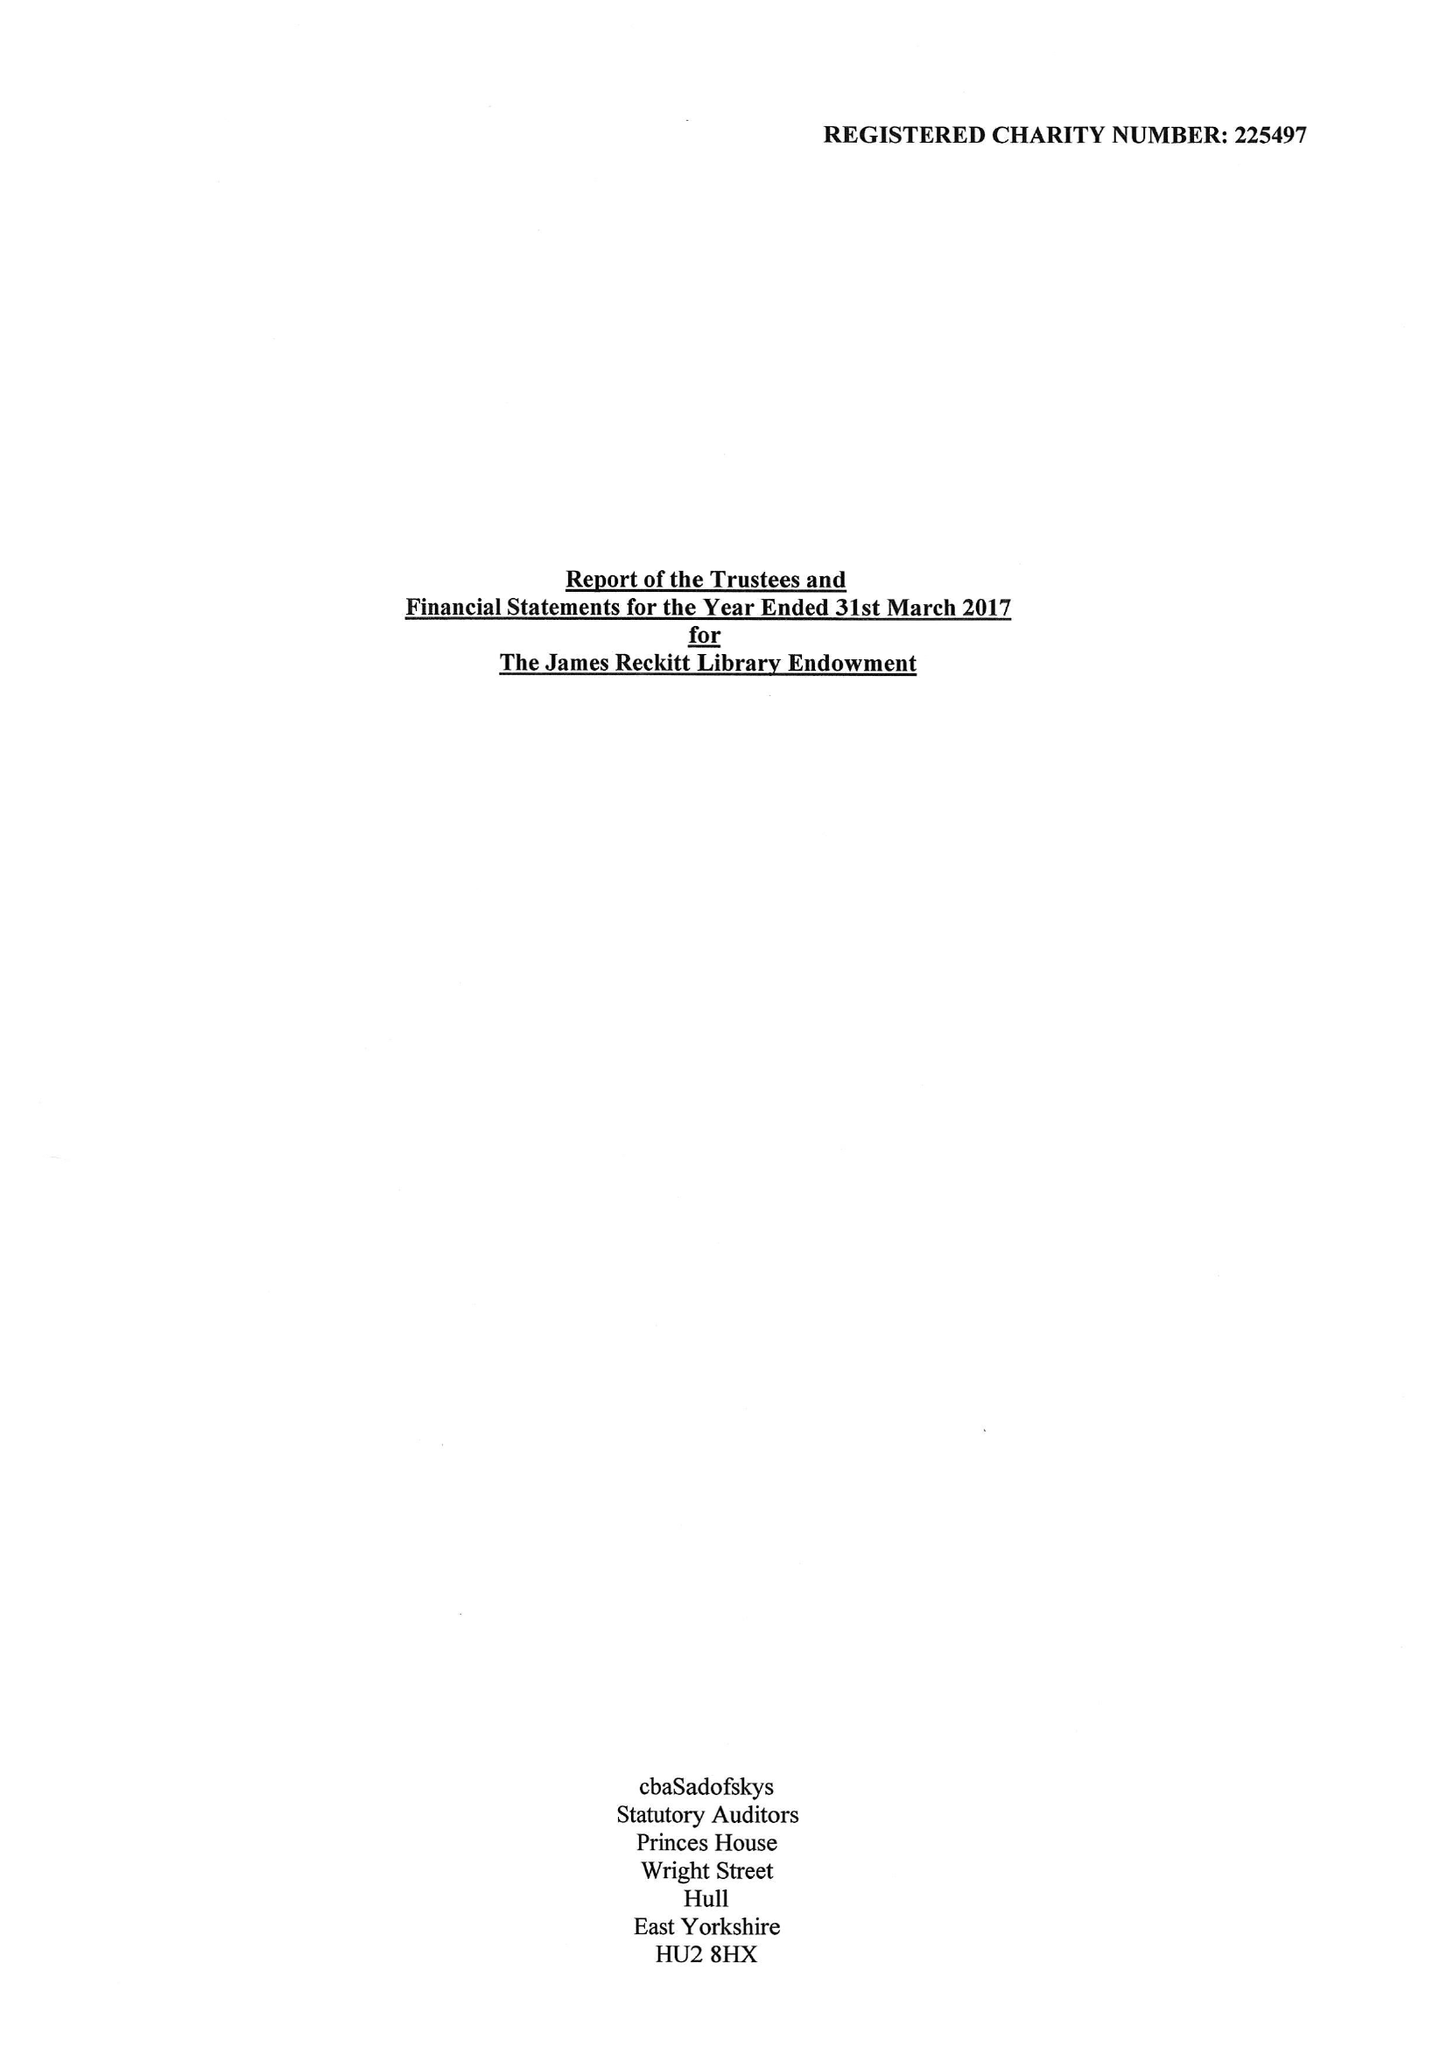What is the value for the address__postcode?
Answer the question using a single word or phrase. HU1 2AB 